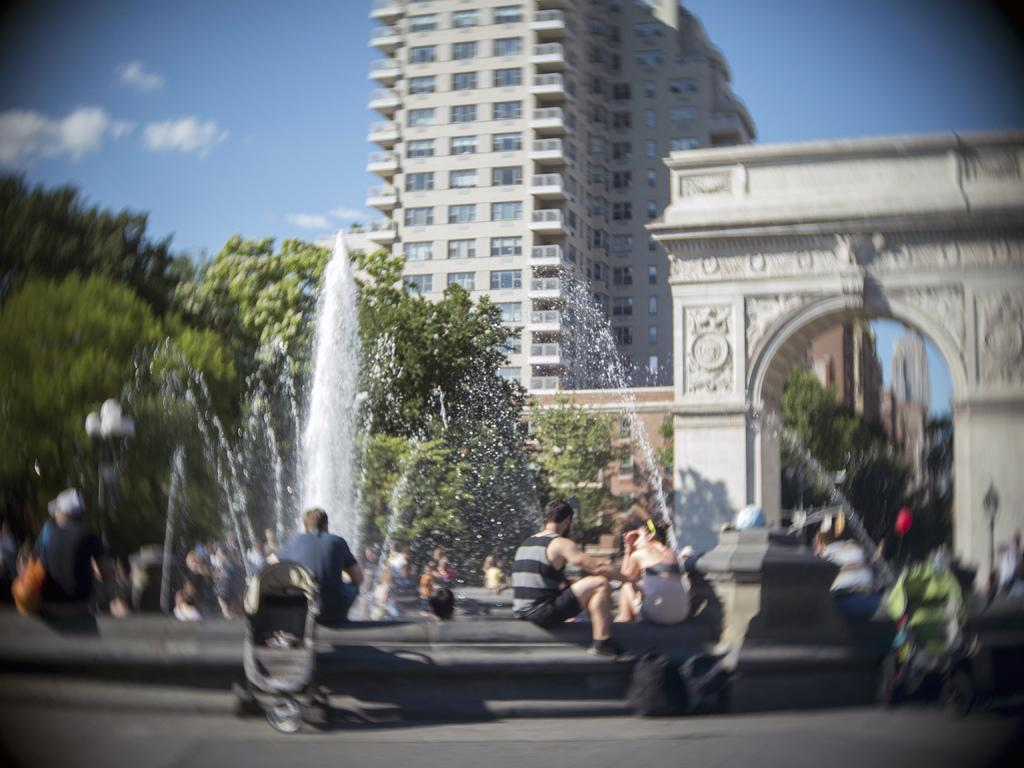What can be seen in the sky in the background of the image? There are clouds in the sky in the background of the image. What type of structures are visible in the background of the image? There are buildings in the background of the image. What architectural feature can be seen in the image? There is an arch in the image. What natural elements are visible in the image? There are trees visible in the image. What type of object can be seen in the image? There is a water fountain in the image. Are there any living beings present in the image? Yes, there are people in the image. What type of cloth is draped over the water fountain in the image? There is no cloth draped over the water fountain in the image. What type of juice can be seen being served to the people in the image? There is no juice being served to the people in the image. 